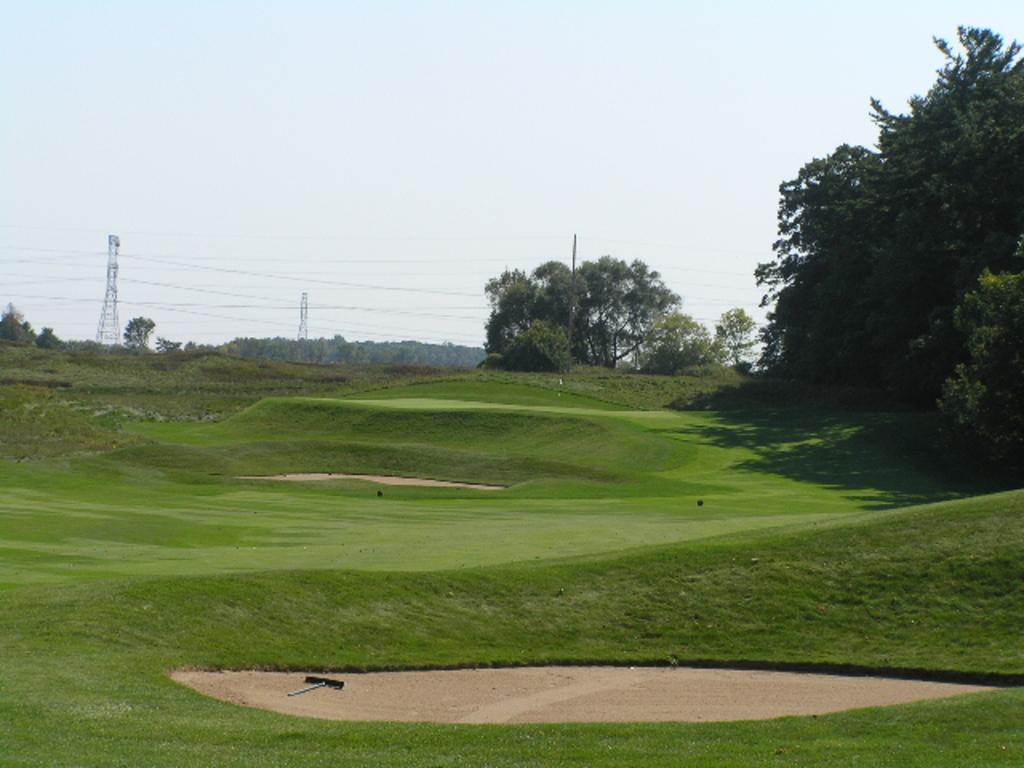In one or two sentences, can you explain what this image depicts? In this image I can see trees,garden,wires and towers. The sky is in white and blue color. 